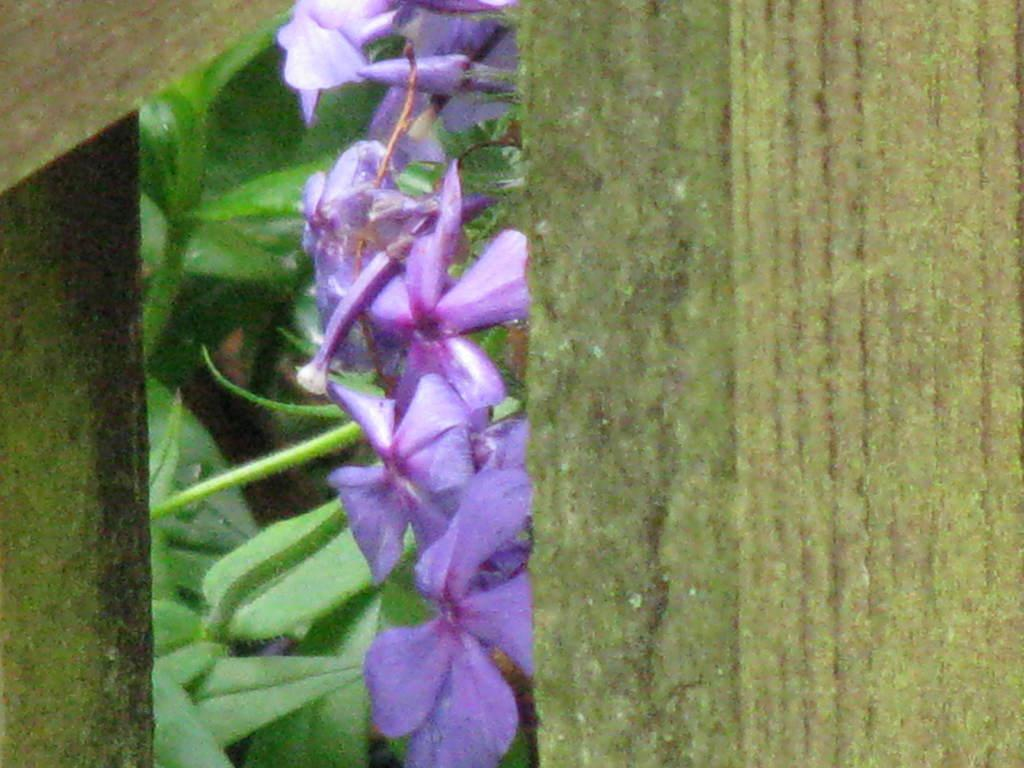What type of plants are visible in the image? There are flowers and leaves in the image. What material are some of the objects made of in the image? There are wooden objects in the image. Where is the nearest zoo to the location depicted in the image? The image does not provide any information about the location or the presence of a zoo, so it cannot be determined from the image. 